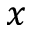<formula> <loc_0><loc_0><loc_500><loc_500>x</formula> 